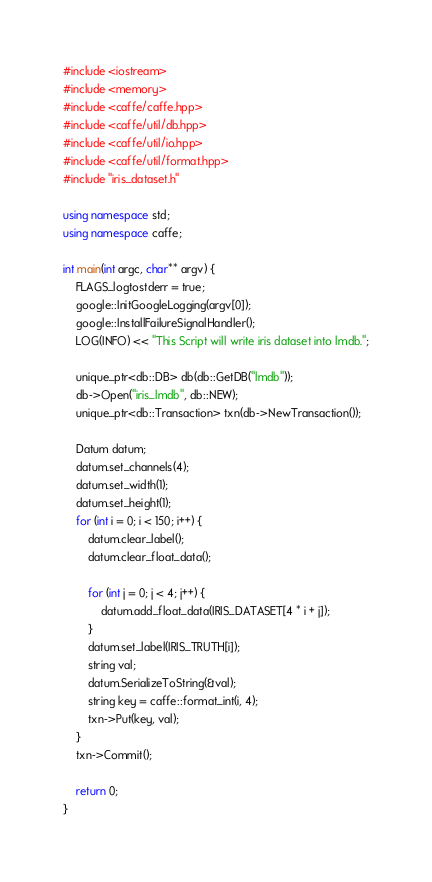Convert code to text. <code><loc_0><loc_0><loc_500><loc_500><_C++_>#include <iostream>
#include <memory>
#include <caffe/caffe.hpp>
#include <caffe/util/db.hpp>
#include <caffe/util/io.hpp>
#include <caffe/util/format.hpp>
#include "iris_dataset.h"

using namespace std;
using namespace caffe;

int main(int argc, char** argv) {
    FLAGS_logtostderr = true;
    google::InitGoogleLogging(argv[0]);
    google::InstallFailureSignalHandler();
    LOG(INFO) << "This Script will write iris dataset into lmdb.";

    unique_ptr<db::DB> db(db::GetDB("lmdb"));
    db->Open("iris_lmdb", db::NEW);
    unique_ptr<db::Transaction> txn(db->NewTransaction());

    Datum datum;
    datum.set_channels(4);
    datum.set_width(1);
    datum.set_height(1);
    for (int i = 0; i < 150; i++) {
        datum.clear_label();
        datum.clear_float_data();

        for (int j = 0; j < 4; j++) {
            datum.add_float_data(IRIS_DATASET[4 * i + j]);
        }
        datum.set_label(IRIS_TRUTH[i]);
        string val;
        datum.SerializeToString(&val);
        string key = caffe::format_int(i, 4);
        txn->Put(key, val);
    }
    txn->Commit();

    return 0;
}
</code> 